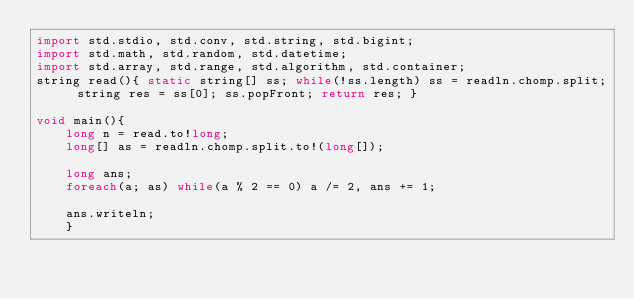Convert code to text. <code><loc_0><loc_0><loc_500><loc_500><_D_>import std.stdio, std.conv, std.string, std.bigint;
import std.math, std.random, std.datetime;
import std.array, std.range, std.algorithm, std.container;
string read(){ static string[] ss; while(!ss.length) ss = readln.chomp.split; string res = ss[0]; ss.popFront; return res; }

void main(){
	long n = read.to!long;
	long[] as = readln.chomp.split.to!(long[]);
	
	long ans;
	foreach(a; as) while(a % 2 == 0) a /= 2, ans += 1;
	
	ans.writeln;
	}</code> 